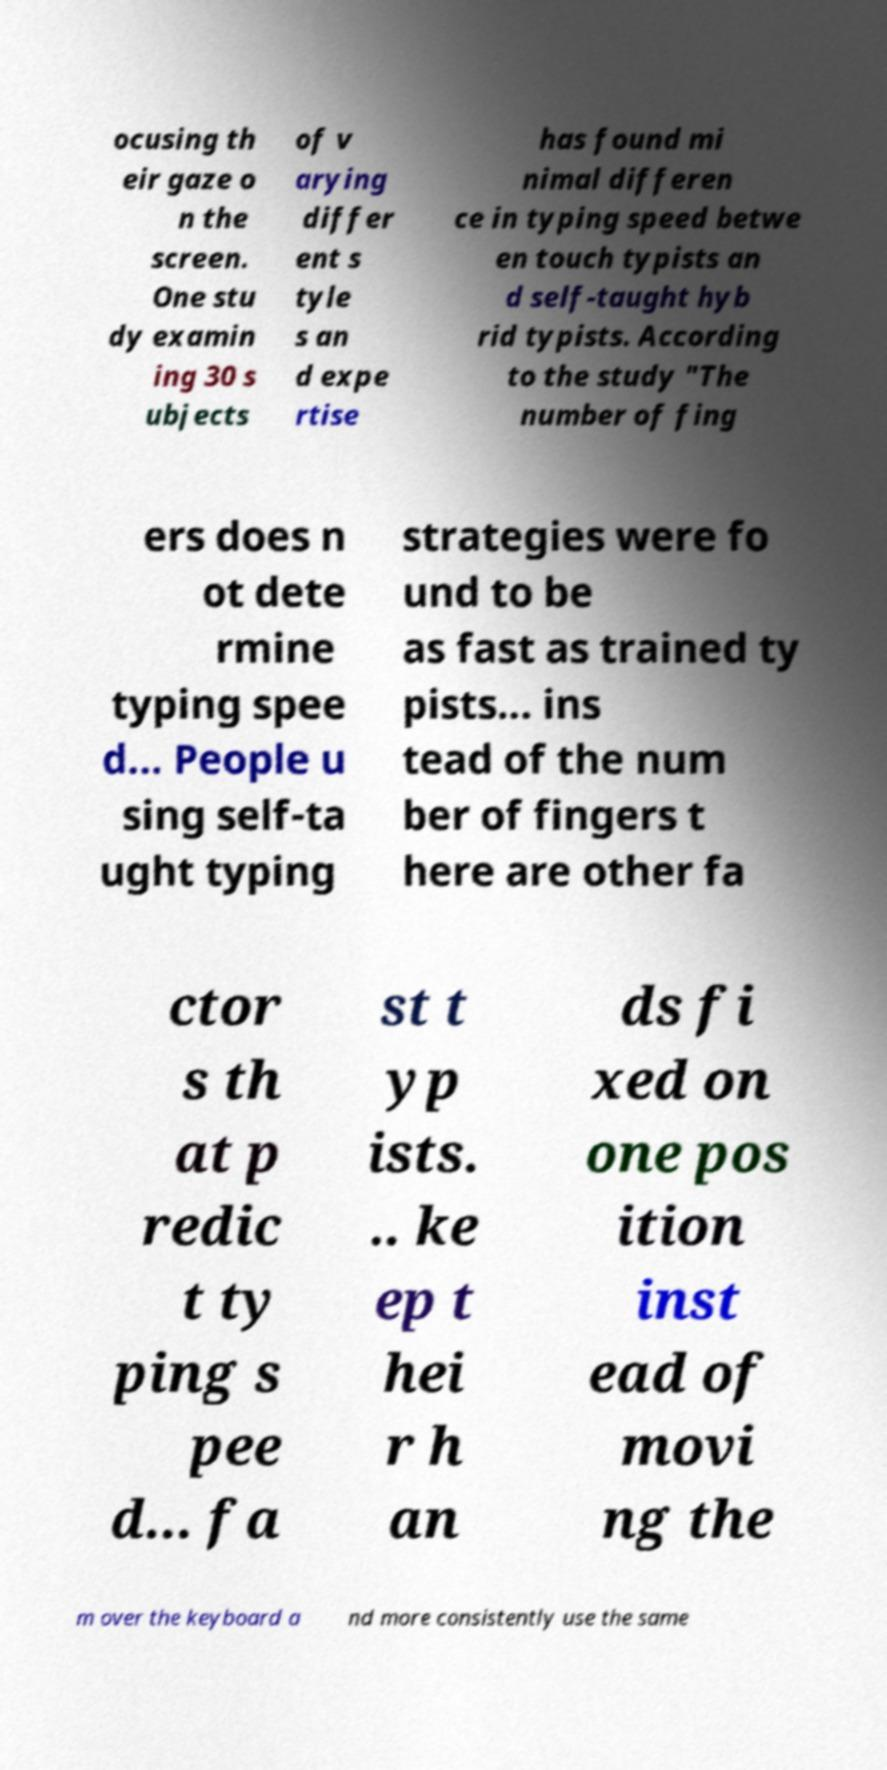Please identify and transcribe the text found in this image. ocusing th eir gaze o n the screen. One stu dy examin ing 30 s ubjects of v arying differ ent s tyle s an d expe rtise has found mi nimal differen ce in typing speed betwe en touch typists an d self-taught hyb rid typists. According to the study "The number of fing ers does n ot dete rmine typing spee d... People u sing self-ta ught typing strategies were fo und to be as fast as trained ty pists... ins tead of the num ber of fingers t here are other fa ctor s th at p redic t ty ping s pee d... fa st t yp ists. .. ke ep t hei r h an ds fi xed on one pos ition inst ead of movi ng the m over the keyboard a nd more consistently use the same 